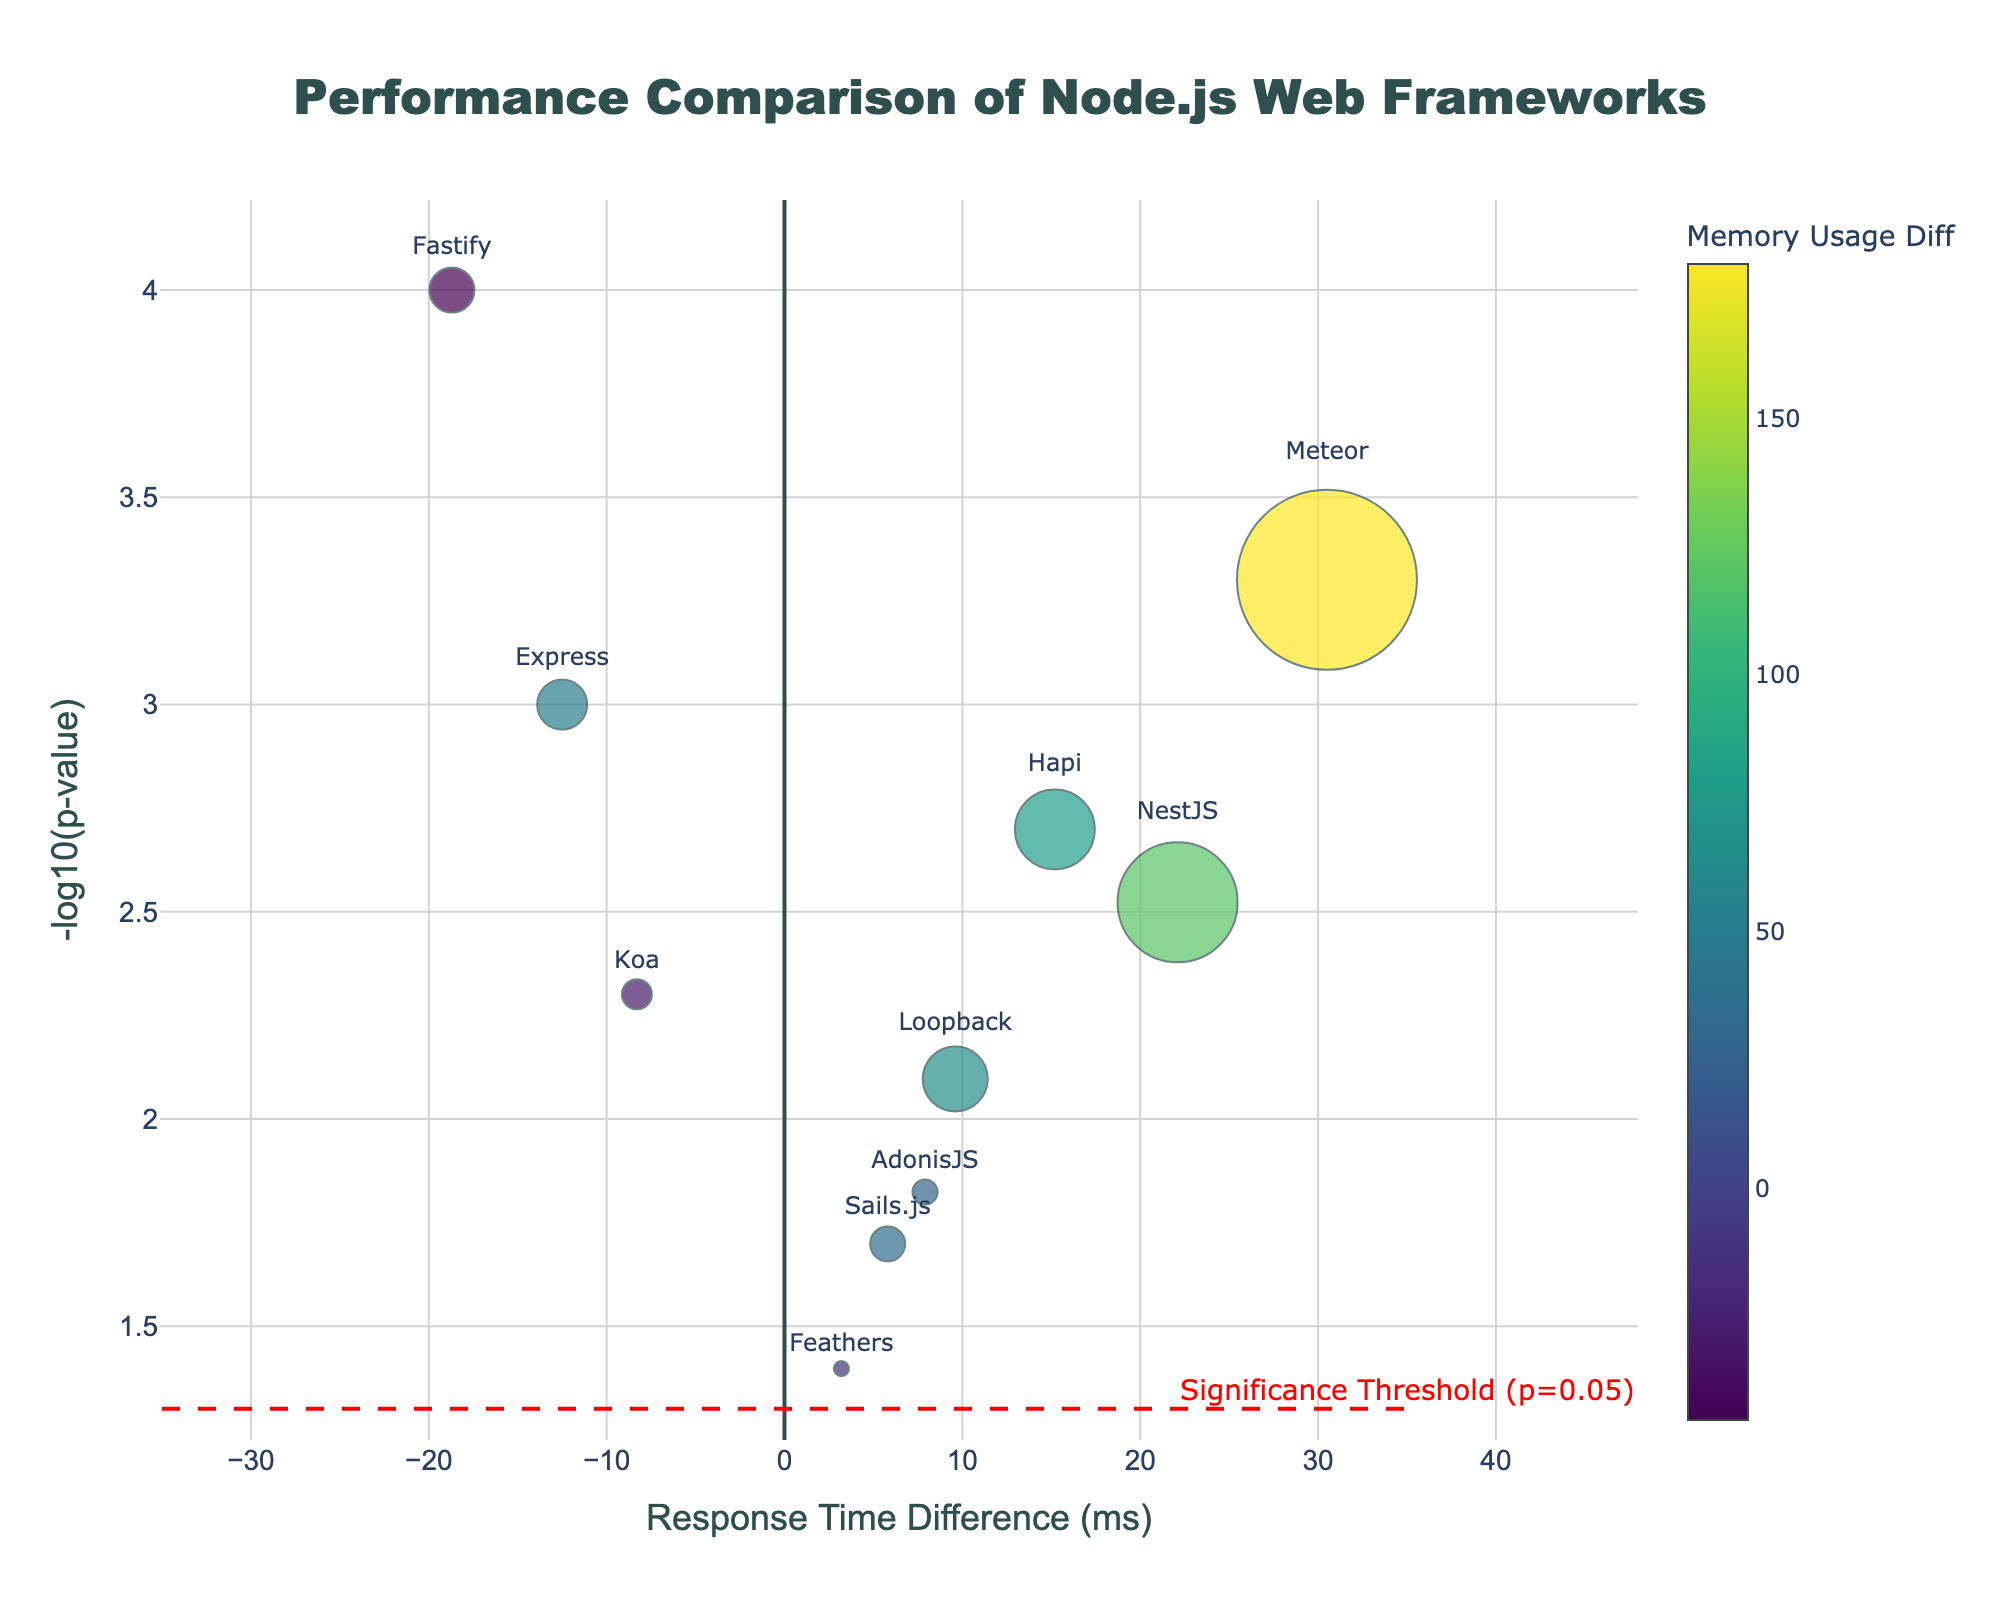What is the title of the figure? The title is located at the top center of the figure and reads "Performance Comparison of Node.js Web Frameworks".
Answer: Performance Comparison of Node.js Web Frameworks How is the memory usage difference represented in the figure? The memory usage difference is represented by the color and size of the markers. Larger memory differences have larger marker sizes, and colors range according to the Viridis scale with a color bar on the right side.
Answer: By color and size of the markers Which framework shows the greatest difference in response time? On the x-axis, which represents the response time difference, the framework farthest from zero shows the greatest difference, which is Meteor at 30.5 ms.
Answer: Meteor Which framework has the smallest p-value? The smallest p-value corresponds to the highest point on the y-axis, which is Fastify at -18.7 response time difference with a -log10(p-value) of around 4.
Answer: Fastify Do any frameworks fall below the significance threshold line? The significance threshold line is displayed as a dashed red line at -log10(0.05). Feathers, AdonisJS, and Sails.js fall below this line.
Answer: Yes How many frameworks have negative response time differences? Frameworks with negative response time differences have markers on the left side of the y-axis. These are Express, Koa, and Fastify.
Answer: Three Which framework has the highest memory usage difference? The memory usage difference is represented by the color of the marker; the brightest marker in green to yellow spectrum has the highest memory usage difference, which is Meteor at 180.
Answer: Meteor What are the combined characteristics of NestJS in terms of response time, memory usage, and significance? NestJS has a response time difference of 22.1 ms (positive), a memory usage difference of 120 (positive), and a p-value corresponding to the -log10 value just above 2.5, which means it's highly significant.
Answer: 22.1 ms, 120, > 2.5 significance Compare the response time differences between Sails.js and AdonisJS. Sails.js has a response time difference of 5.8 ms, and AdonisJS has a response time difference of 7.9 ms. To compare, AdonisJS has a higher response time difference than Sails.js by 2.1 ms.
Answer: AdonisJS is 2.1 ms higher than Sails.js Which frameworks are more efficient in reducing response times and by how much, considering only significant results? Frameworks with negative response times and significant results (above the threshold) are Express and Fastify. Express reduces response time by 12.5 ms and Fastify by 18.7 ms. Fastify reduces response time more effectively by 6.2 ms compared to Express.
Answer: Fastify reduces by 18.7 ms, Express by 12.5 ms, Fastify is more efficient by 6.2 ms 